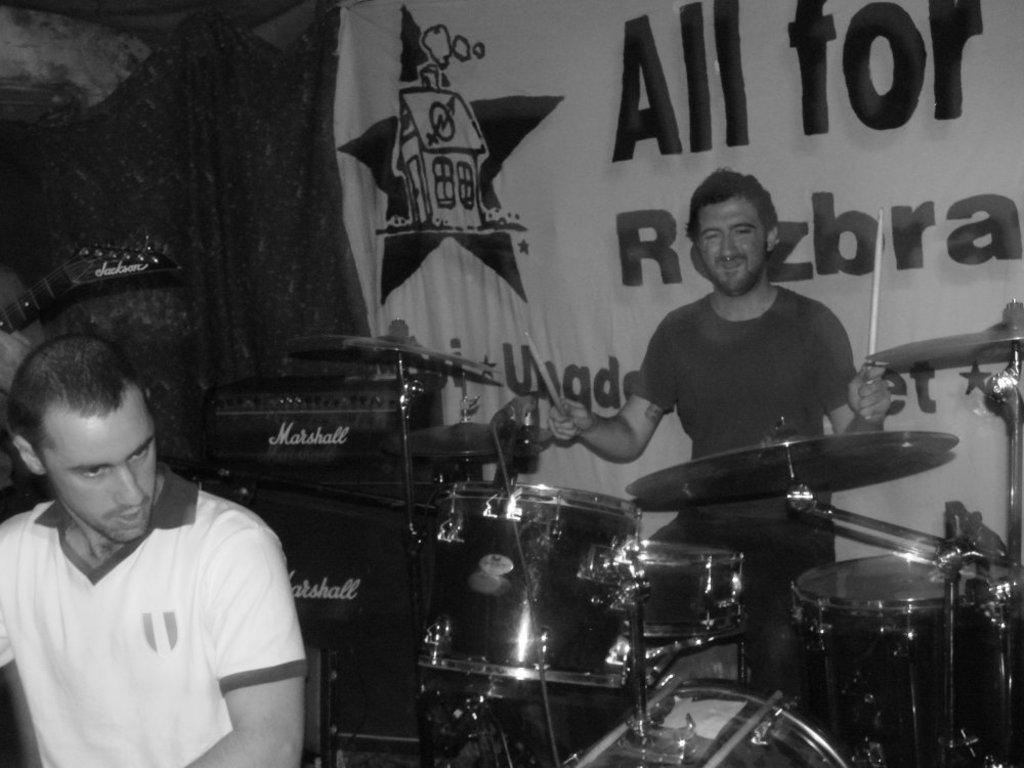What is the main subject of the image? There is a man sitting and playing a band in the image. Can you describe the other person in the image? There is another man on the left side of the image. What can be seen in the background of the image? There is a banner visible in the background of the image. What type of protest is taking place in the image? There is no protest present in the image; it features a man playing a band and another person on the left side. How does the digestion process of the man playing the band appear in the image? There is no indication of the man's digestion process in the image; it focuses on his musical performance. 